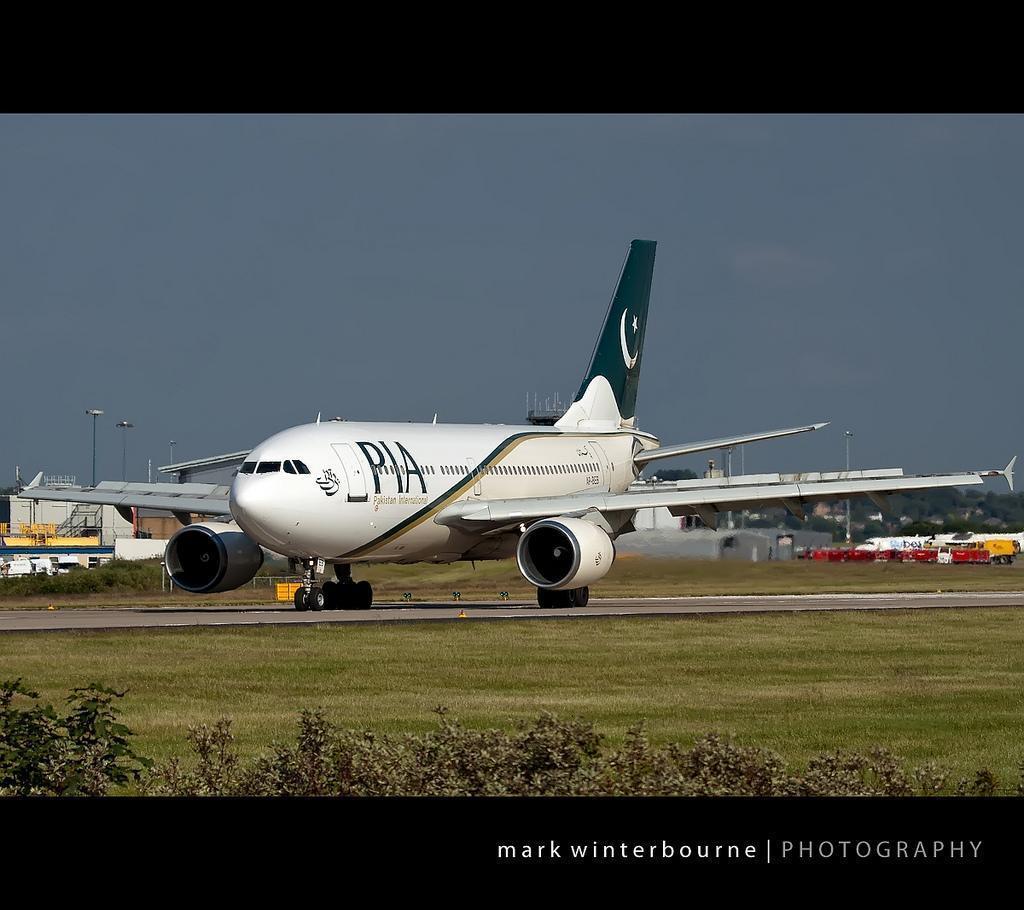How many visible engines does the plane have?
Give a very brief answer. 2. 